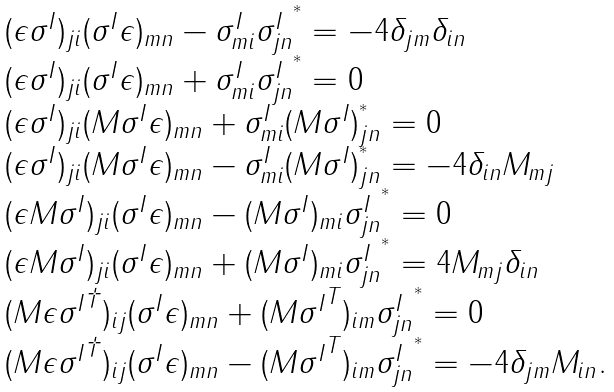<formula> <loc_0><loc_0><loc_500><loc_500>\begin{array} { l } ( \epsilon \sigma ^ { I } ) _ { j i } ( \sigma ^ { I } \epsilon ) _ { m n } - \sigma ^ { I } _ { m i } { \sigma ^ { I } _ { j n } } ^ { ^ { * } } = - 4 \delta _ { j m } \delta _ { i n } \\ ( \epsilon \sigma ^ { I } ) _ { j i } ( \sigma ^ { I } \epsilon ) _ { m n } + \sigma ^ { I } _ { m i } { \sigma ^ { I } _ { j n } } ^ { ^ { * } } = 0 \\ ( \epsilon \sigma ^ { I } ) _ { j i } ( M \sigma ^ { I } \epsilon ) _ { m n } + \sigma ^ { I } _ { m i } ( M \sigma ^ { I } ) _ { j n } ^ { ^ { * } } = 0 \\ ( \epsilon \sigma ^ { I } ) _ { j i } ( M \sigma ^ { I } \epsilon ) _ { m n } - \sigma ^ { I } _ { m i } ( M \sigma ^ { I } ) _ { j n } ^ { ^ { * } } = - 4 \delta _ { i n } M _ { m j } \\ ( \epsilon M \sigma ^ { I } ) _ { j i } ( \sigma ^ { I } \epsilon ) _ { m n } - ( M \sigma ^ { I } ) _ { m i } { \sigma ^ { I } _ { j n } } ^ { ^ { * } } = 0 \\ ( \epsilon M \sigma ^ { I } ) _ { j i } ( \sigma ^ { I } \epsilon ) _ { m n } + ( M \sigma ^ { I } ) _ { m i } { \sigma ^ { I } _ { j n } } ^ { ^ { * } } = 4 M _ { m j } \delta _ { i n } \\ ( M \epsilon { \sigma ^ { I } } ^ { \dagger } ) _ { i j } ( \sigma ^ { I } \epsilon ) _ { m n } + ( M { \sigma ^ { I } } ^ { T } ) _ { i m } { \sigma ^ { I } _ { j n } } ^ { ^ { * } } = 0 \\ ( M \epsilon { \sigma ^ { I } } ^ { \dagger } ) _ { i j } ( \sigma ^ { I } \epsilon ) _ { m n } - ( M { \sigma ^ { I } } ^ { T } ) _ { i m } { \sigma ^ { I } _ { j n } } ^ { ^ { * } } = - 4 \delta _ { j m } M _ { i n } . \end{array}</formula> 